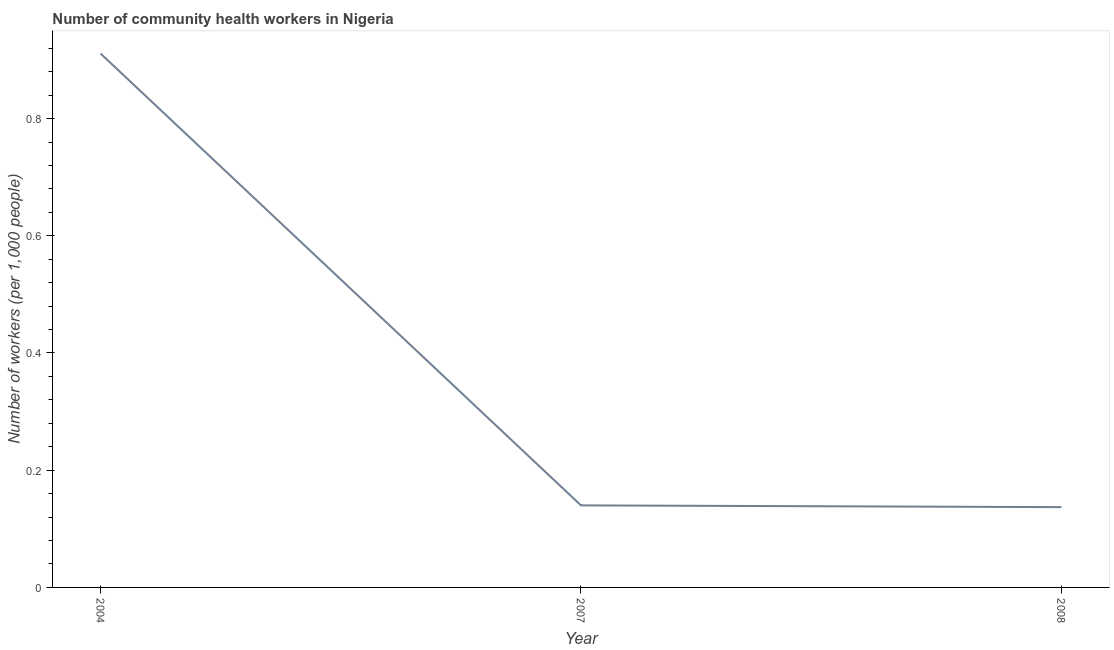What is the number of community health workers in 2007?
Ensure brevity in your answer.  0.14. Across all years, what is the maximum number of community health workers?
Ensure brevity in your answer.  0.91. Across all years, what is the minimum number of community health workers?
Offer a very short reply. 0.14. In which year was the number of community health workers maximum?
Keep it short and to the point. 2004. What is the sum of the number of community health workers?
Provide a succinct answer. 1.19. What is the difference between the number of community health workers in 2007 and 2008?
Make the answer very short. 0. What is the average number of community health workers per year?
Make the answer very short. 0.4. What is the median number of community health workers?
Your response must be concise. 0.14. Do a majority of the years between 2007 and 2008 (inclusive) have number of community health workers greater than 0.36 ?
Provide a short and direct response. No. What is the ratio of the number of community health workers in 2004 to that in 2008?
Make the answer very short. 6.65. Is the number of community health workers in 2004 less than that in 2007?
Make the answer very short. No. What is the difference between the highest and the second highest number of community health workers?
Your response must be concise. 0.77. What is the difference between the highest and the lowest number of community health workers?
Ensure brevity in your answer.  0.77. In how many years, is the number of community health workers greater than the average number of community health workers taken over all years?
Your answer should be compact. 1. Are the values on the major ticks of Y-axis written in scientific E-notation?
Your response must be concise. No. Does the graph contain grids?
Provide a short and direct response. No. What is the title of the graph?
Your response must be concise. Number of community health workers in Nigeria. What is the label or title of the Y-axis?
Ensure brevity in your answer.  Number of workers (per 1,0 people). What is the Number of workers (per 1,000 people) in 2004?
Make the answer very short. 0.91. What is the Number of workers (per 1,000 people) in 2007?
Your answer should be compact. 0.14. What is the Number of workers (per 1,000 people) of 2008?
Give a very brief answer. 0.14. What is the difference between the Number of workers (per 1,000 people) in 2004 and 2007?
Provide a succinct answer. 0.77. What is the difference between the Number of workers (per 1,000 people) in 2004 and 2008?
Make the answer very short. 0.77. What is the difference between the Number of workers (per 1,000 people) in 2007 and 2008?
Your answer should be very brief. 0. What is the ratio of the Number of workers (per 1,000 people) in 2004 to that in 2007?
Keep it short and to the point. 6.51. What is the ratio of the Number of workers (per 1,000 people) in 2004 to that in 2008?
Offer a very short reply. 6.65. 